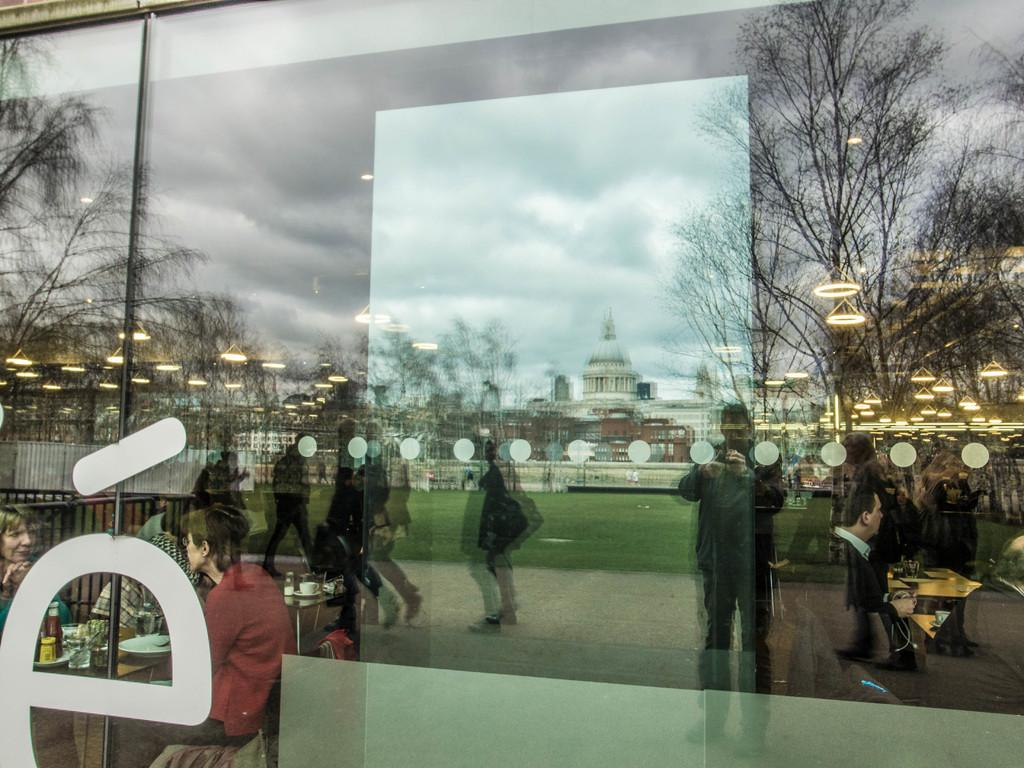What object is present in the image that can reflect images? There is a glass in the image that can reflect images. What can be seen inside the glass? A palace is visible in the glass. What type of natural environment is present in the image? There are trees in the image. What else can be seen in the glass besides the palace? People are reflecting in the glass. Can you see the family wearing crowns in the image? There is no family or crowns present in the image. What page is being turned in the image? There is no book or page-turning activity depicted in the image. 